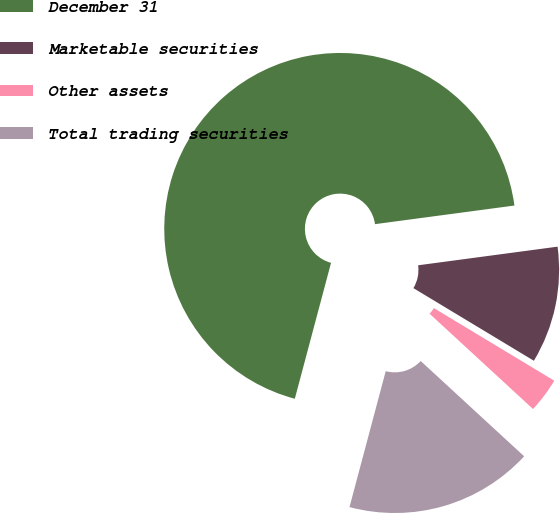<chart> <loc_0><loc_0><loc_500><loc_500><pie_chart><fcel>December 31<fcel>Marketable securities<fcel>Other assets<fcel>Total trading securities<nl><fcel>68.74%<fcel>10.75%<fcel>3.21%<fcel>17.3%<nl></chart> 